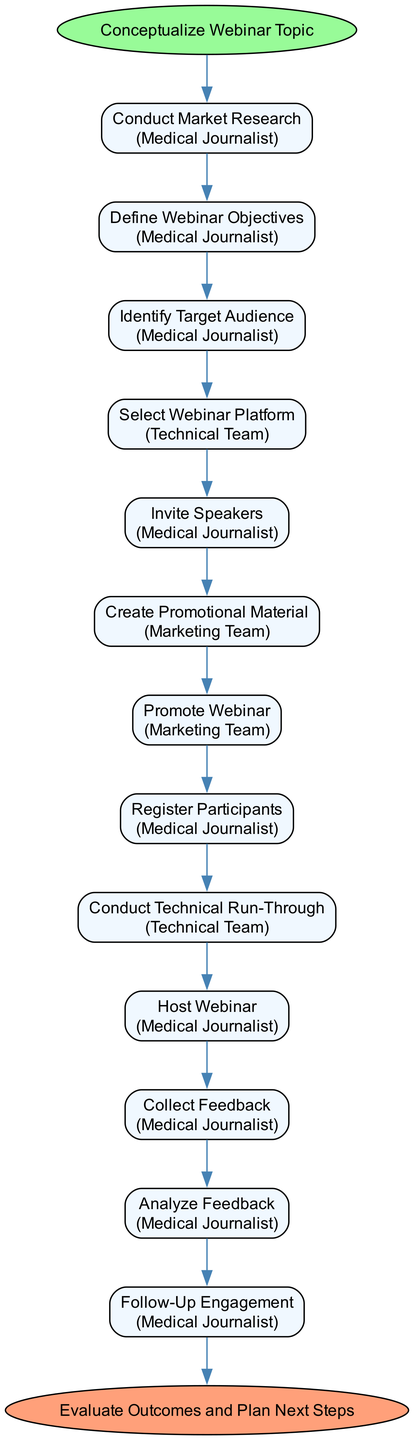What is the first step in the diagram? The first step, also known as the start event, is labeled "Conceptualize Webinar Topic." It appears at the top of the diagram and initiates the sequence of activities.
Answer: Conceptualize Webinar Topic How many activities are listed in the diagram? Counting the activities from the provided data, there are a total of 12 activities shown in the diagram from "Conduct Market Research" to "Follow-Up Engagement."
Answer: 12 What role is responsible for hosting the webinar? The role responsible for hosting the webinar is the "Medical Journalist," as indicated in the activity labeled "Host Webinar."
Answer: Medical Journalist Which activity comes immediately after "Invite Speakers"? Upon reviewing the sequential flow in the diagram, the activity that follows "Invite Speakers" is "Create Promotional Material." This indicates the order of tasks to be completed.
Answer: Create Promotional Material What is the end event of the diagram? The end event is labeled "Evaluate Outcomes and Plan Next Steps." It signifies the conclusion of the entire process outlined in the diagram.
Answer: Evaluate Outcomes and Plan Next Steps How many unique participants are involved in the activities? By examining the participants listed in the activities, we can identify three unique participants: "Medical Journalist," "Technical Team," and "Marketing Team."
Answer: 3 Which activity is performed last before the follow-up engagement? The activity that occurs just before "Follow-Up Engagement" is "Analyze Feedback." This indicates that feedback analysis directly leads to engaging with participants afterward.
Answer: Analyze Feedback What is the participant responsible for conducting technical run-throughs? The participant responsible for conducting technical run-throughs is the "Technical Team," as specified in the respective activity node.
Answer: Technical Team Which activity involves determining audience segments? The activity focused on determining audience segments is "Identify Target Audience," which signifies that understanding the audience is a critical step in the organization process.
Answer: Identify Target Audience 